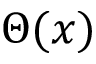Convert formula to latex. <formula><loc_0><loc_0><loc_500><loc_500>\Theta ( x )</formula> 